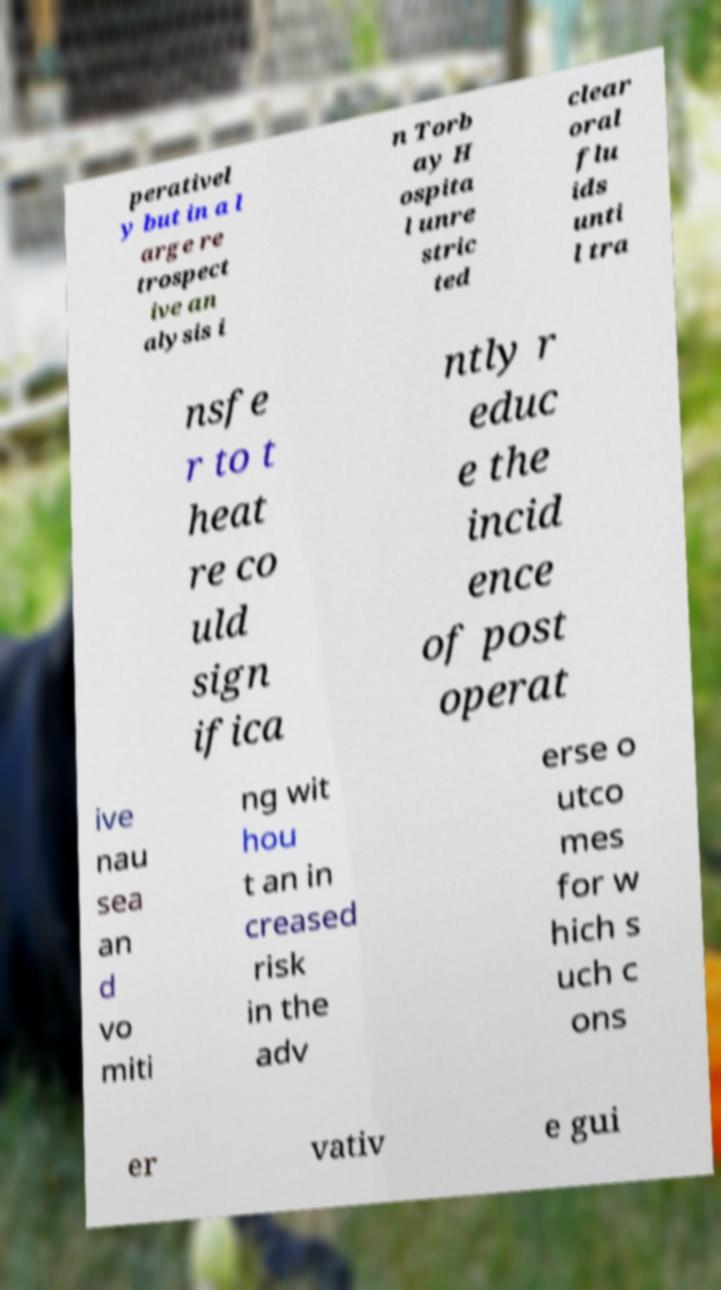Could you assist in decoding the text presented in this image and type it out clearly? perativel y but in a l arge re trospect ive an alysis i n Torb ay H ospita l unre stric ted clear oral flu ids unti l tra nsfe r to t heat re co uld sign ifica ntly r educ e the incid ence of post operat ive nau sea an d vo miti ng wit hou t an in creased risk in the adv erse o utco mes for w hich s uch c ons er vativ e gui 